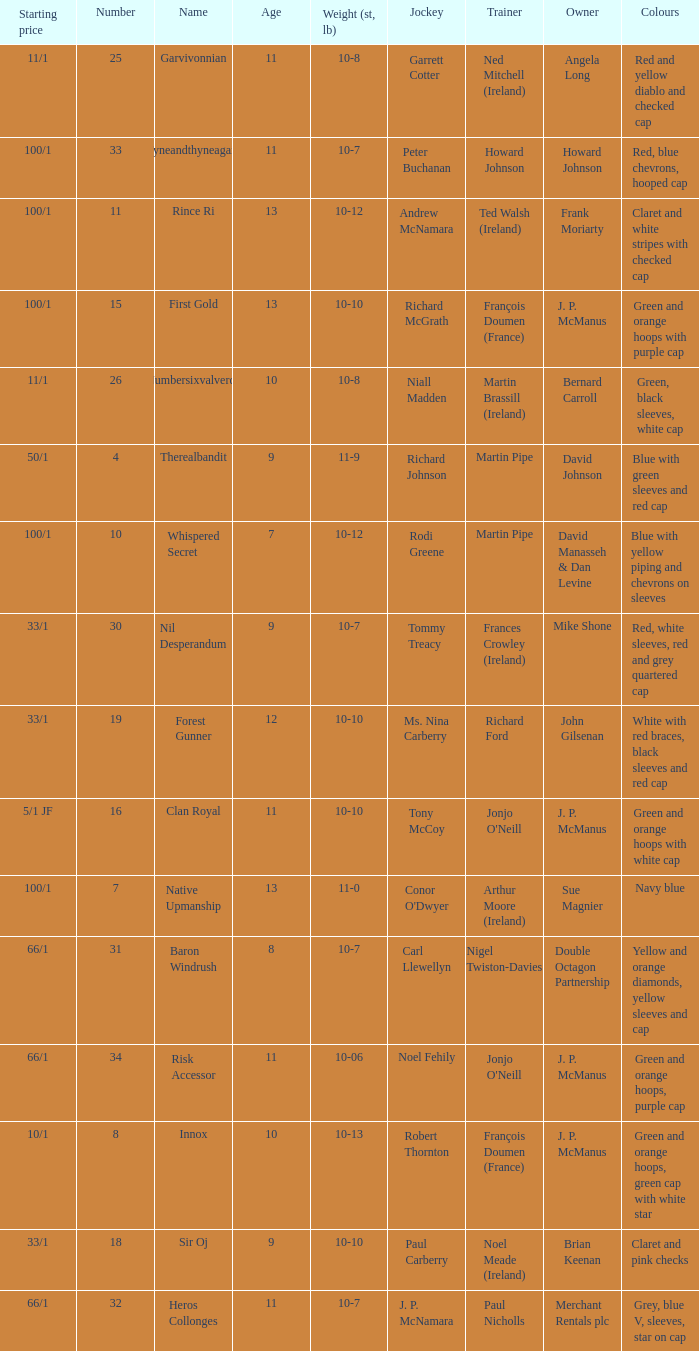Give me the full table as a dictionary. {'header': ['Starting price', 'Number', 'Name', 'Age', 'Weight (st, lb)', 'Jockey', 'Trainer', 'Owner', 'Colours'], 'rows': [['11/1', '25', 'Garvivonnian', '11', '10-8', 'Garrett Cotter', 'Ned Mitchell (Ireland)', 'Angela Long', 'Red and yellow diablo and checked cap'], ['100/1', '33', 'Tyneandthyneagain', '11', '10-7', 'Peter Buchanan', 'Howard Johnson', 'Howard Johnson', 'Red, blue chevrons, hooped cap'], ['100/1', '11', 'Rince Ri', '13', '10-12', 'Andrew McNamara', 'Ted Walsh (Ireland)', 'Frank Moriarty', 'Claret and white stripes with checked cap'], ['100/1', '15', 'First Gold', '13', '10-10', 'Richard McGrath', 'François Doumen (France)', 'J. P. McManus', 'Green and orange hoops with purple cap'], ['11/1', '26', 'Numbersixvalverde', '10', '10-8', 'Niall Madden', 'Martin Brassill (Ireland)', 'Bernard Carroll', 'Green, black sleeves, white cap'], ['50/1', '4', 'Therealbandit', '9', '11-9', 'Richard Johnson', 'Martin Pipe', 'David Johnson', 'Blue with green sleeves and red cap'], ['100/1', '10', 'Whispered Secret', '7', '10-12', 'Rodi Greene', 'Martin Pipe', 'David Manasseh & Dan Levine', 'Blue with yellow piping and chevrons on sleeves'], ['33/1', '30', 'Nil Desperandum', '9', '10-7', 'Tommy Treacy', 'Frances Crowley (Ireland)', 'Mike Shone', 'Red, white sleeves, red and grey quartered cap'], ['33/1', '19', 'Forest Gunner', '12', '10-10', 'Ms. Nina Carberry', 'Richard Ford', 'John Gilsenan', 'White with red braces, black sleeves and red cap'], ['5/1 JF', '16', 'Clan Royal', '11', '10-10', 'Tony McCoy', "Jonjo O'Neill", 'J. P. McManus', 'Green and orange hoops with white cap'], ['100/1', '7', 'Native Upmanship', '13', '11-0', "Conor O'Dwyer", 'Arthur Moore (Ireland)', 'Sue Magnier', 'Navy blue'], ['66/1', '31', 'Baron Windrush', '8', '10-7', 'Carl Llewellyn', 'Nigel Twiston-Davies', 'Double Octagon Partnership', 'Yellow and orange diamonds, yellow sleeves and cap'], ['66/1', '34', 'Risk Accessor', '11', '10-06', 'Noel Fehily', "Jonjo O'Neill", 'J. P. McManus', 'Green and orange hoops, purple cap'], ['10/1', '8', 'Innox', '10', '10-13', 'Robert Thornton', 'François Doumen (France)', 'J. P. McManus', 'Green and orange hoops, green cap with white star'], ['33/1', '18', 'Sir Oj', '9', '10-10', 'Paul Carberry', 'Noel Meade (Ireland)', 'Brian Keenan', 'Claret and pink checks'], ['66/1', '32', 'Heros Collonges', '11', '10-7', 'J. P. McNamara', 'Paul Nicholls', 'Merchant Rentals plc', 'Grey, blue V, sleeves, star on cap']]} What was the name of the entrant with an owner named David Johnson? Therealbandit. 